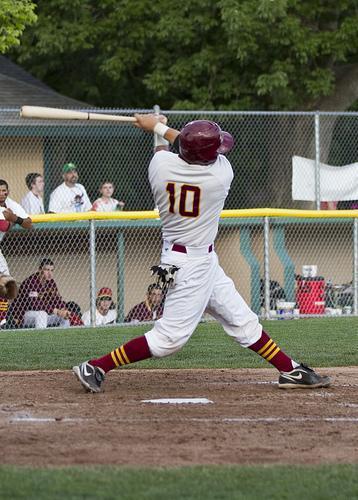How many stripes are on the man's socks?
Give a very brief answer. 3. 